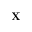<formula> <loc_0><loc_0><loc_500><loc_500>X</formula> 